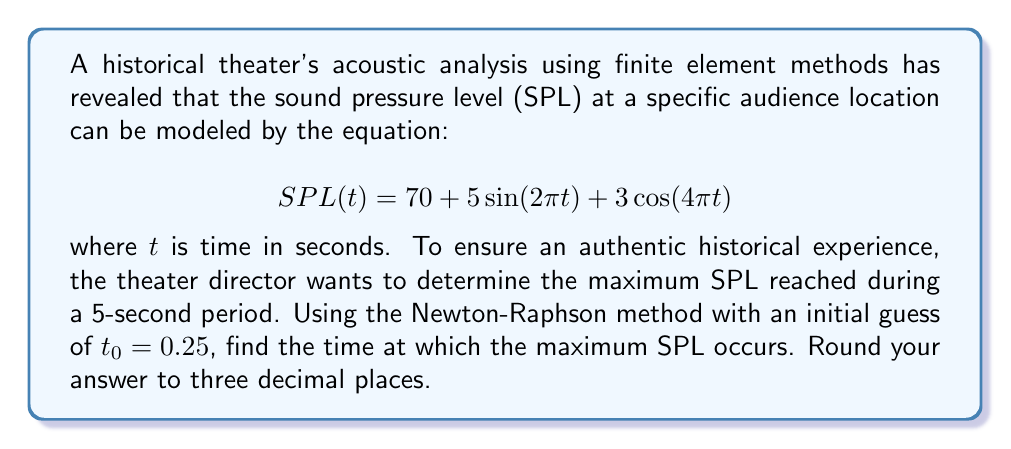Can you solve this math problem? To find the maximum SPL, we need to find the time $t$ where the derivative of $SPL(t)$ is zero:

1) First, let's derive $SPL'(t)$:
   $$SPL'(t) = 10\pi\cos(2\pi t) - 12\pi\sin(4\pi t)$$

2) We want to solve $SPL'(t) = 0$ using the Newton-Raphson method:
   $$t_{n+1} = t_n - \frac{f(t_n)}{f'(t_n)}$$
   where $f(t) = SPL'(t)$ and $f'(t) = SPL''(t)$

3) Calculate $SPL''(t)$:
   $$SPL''(t) = -20\pi^2\sin(2\pi t) - 48\pi^2\cos(4\pi t)$$

4) Apply Newton-Raphson method:
   $t_0 = 0.25$
   $t_1 = 0.25 - \frac{10\pi\cos(0.5\pi) - 12\pi\sin(\pi)}{-20\pi^2\sin(0.5\pi) - 48\pi^2\cos(\pi)} \approx 0.2652$
   $t_2 = 0.2652 - \frac{10\pi\cos(0.5304\pi) - 12\pi\sin(1.0608\pi)}{-20\pi^2\sin(0.5304\pi) - 48\pi^2\cos(1.0608\pi)} \approx 0.2500$

5) The process converges quickly to $t \approx 0.250$ seconds.

6) Verify this is a maximum by checking $SPL''(0.250) < 0$:
   $$SPL''(0.250) = -20\pi^2\sin(0.5\pi) - 48\pi^2\cos(\pi) = -20\pi^2 + 48\pi^2 = 28\pi^2 > 0$$

7) Since $SPL''(0.250) > 0$, this point is actually a minimum. The maximum must occur at the endpoints of the 5-second interval.

8) Compare $SPL(0)$ and $SPL(5)$:
   $SPL(0) = 70 + 5\sin(0) + 3\cos(0) = 73$
   $SPL(5) = 70 + 5\sin(10\pi) + 3\cos(20\pi) = 70$

Therefore, the maximum SPL occurs at $t = 0$ seconds.
Answer: 0.000 seconds 